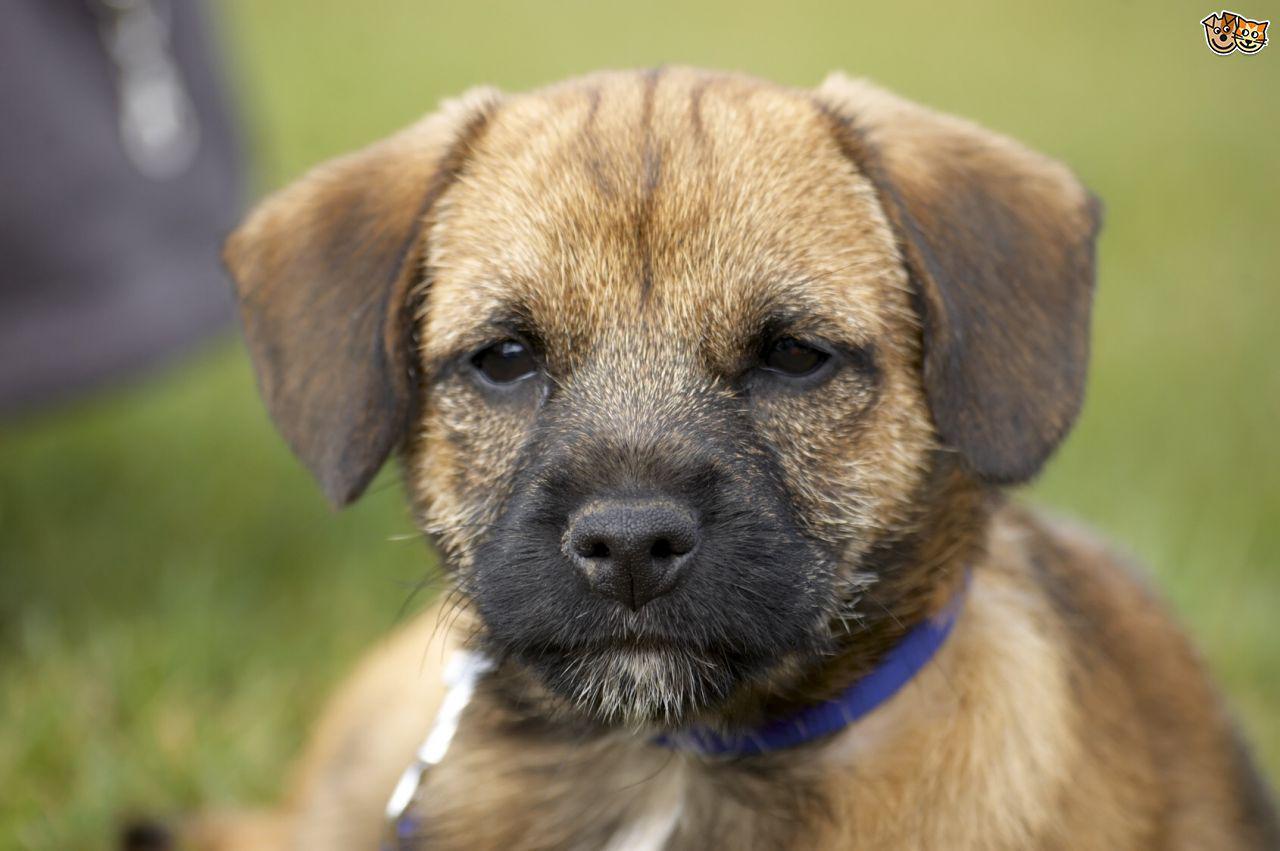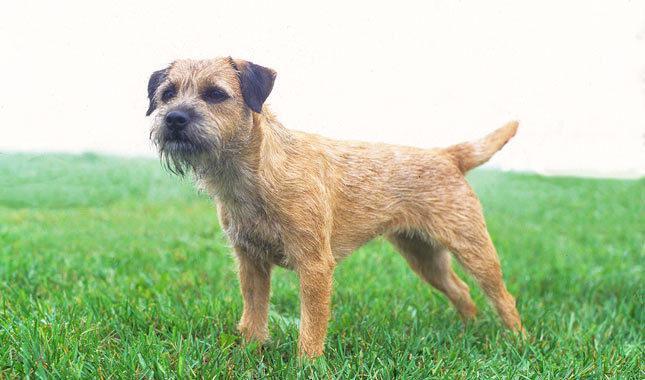The first image is the image on the left, the second image is the image on the right. Given the left and right images, does the statement "An image shows one dog facing the camera directly, with mouth open." hold true? Answer yes or no. No. 